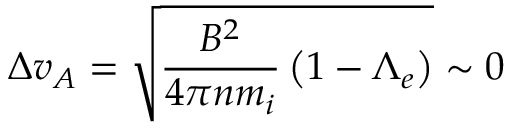<formula> <loc_0><loc_0><loc_500><loc_500>\Delta v _ { A } = \sqrt { \frac { B ^ { 2 } } { 4 \pi n m _ { i } } \left ( 1 - \Lambda _ { e } \right ) } \sim 0</formula> 